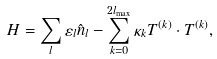Convert formula to latex. <formula><loc_0><loc_0><loc_500><loc_500>H = \sum _ { l } \varepsilon _ { l } \hat { n } _ { l } - \sum _ { k = 0 } ^ { 2 l _ { \max } } \kappa _ { k } T ^ { ( k ) } \cdot T ^ { ( k ) } ,</formula> 